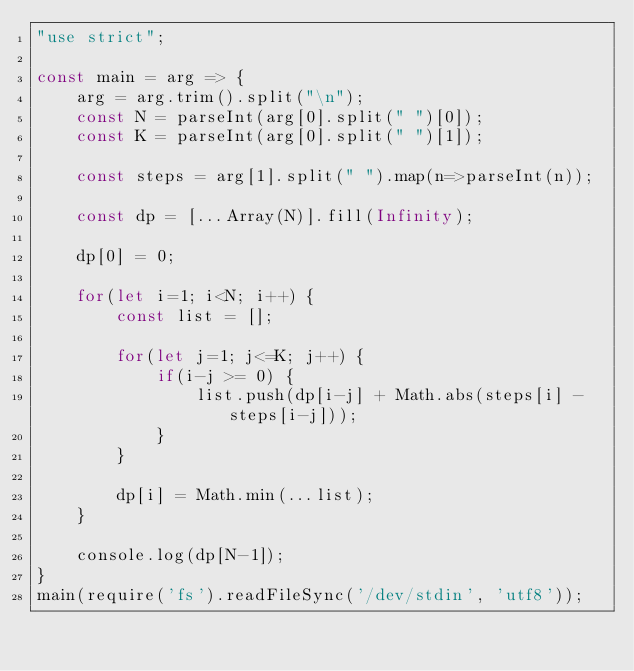<code> <loc_0><loc_0><loc_500><loc_500><_JavaScript_>"use strict";
    
const main = arg => {
    arg = arg.trim().split("\n");
    const N = parseInt(arg[0].split(" ")[0]);
    const K = parseInt(arg[0].split(" ")[1]);
    
    const steps = arg[1].split(" ").map(n=>parseInt(n));
    
    const dp = [...Array(N)].fill(Infinity);
    
    dp[0] = 0;
    
    for(let i=1; i<N; i++) {
        const list = [];
        
        for(let j=1; j<=K; j++) {
            if(i-j >= 0) {
                list.push(dp[i-j] + Math.abs(steps[i] - steps[i-j]));
            }
        }
        
        dp[i] = Math.min(...list);
    }
    
    console.log(dp[N-1]);
}
main(require('fs').readFileSync('/dev/stdin', 'utf8'));</code> 